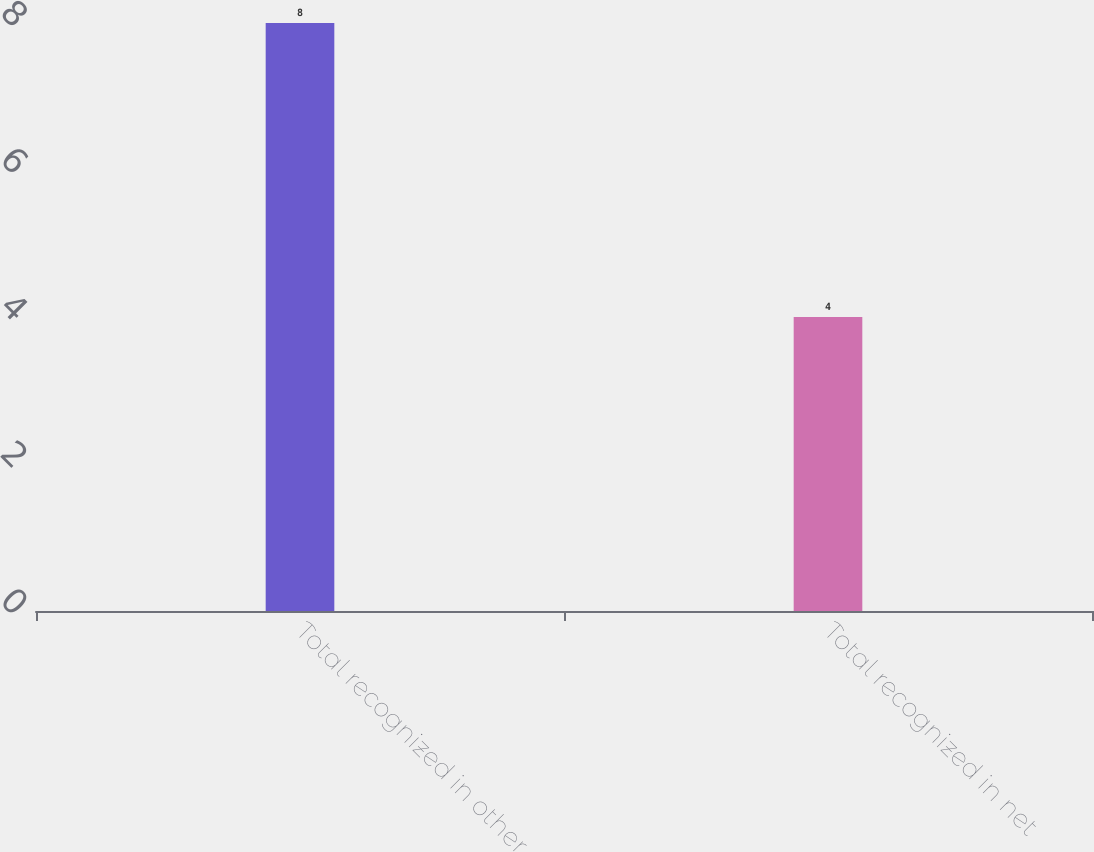Convert chart. <chart><loc_0><loc_0><loc_500><loc_500><bar_chart><fcel>Total recognized in other<fcel>Total recognized in net<nl><fcel>8<fcel>4<nl></chart> 